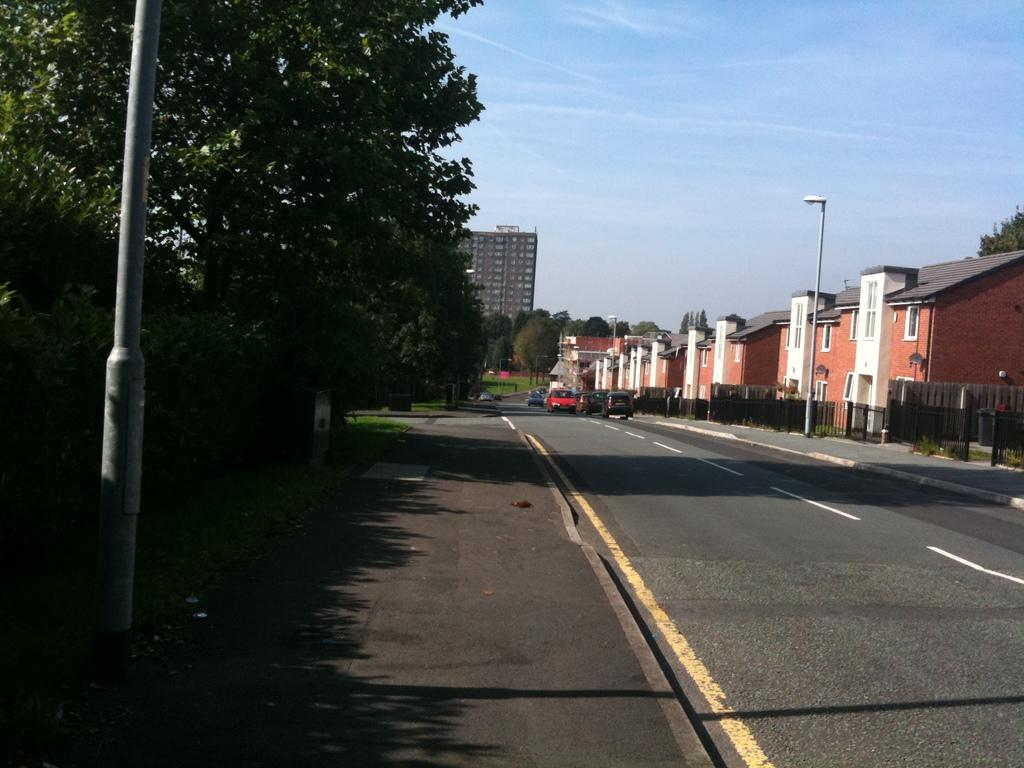What type of structures can be seen in the image? There are buildings in the image. What else is present in the image besides buildings? There are vehicles, a fence, trees, poles, grass, and the sky visible in the image. Can you describe the ground in the image? The ground is visible in the image. What might be used to separate areas or provide boundaries in the image? The fence in the image might be used to separate areas or provide boundaries. Can you tell me how many goldfish are swimming in the grass in the image? There are no goldfish present in the image; it features buildings, vehicles, a fence, trees, poles, grass, and the sky. What holiday is being celebrated in the image? There is no indication of a holiday being celebrated in the image. 